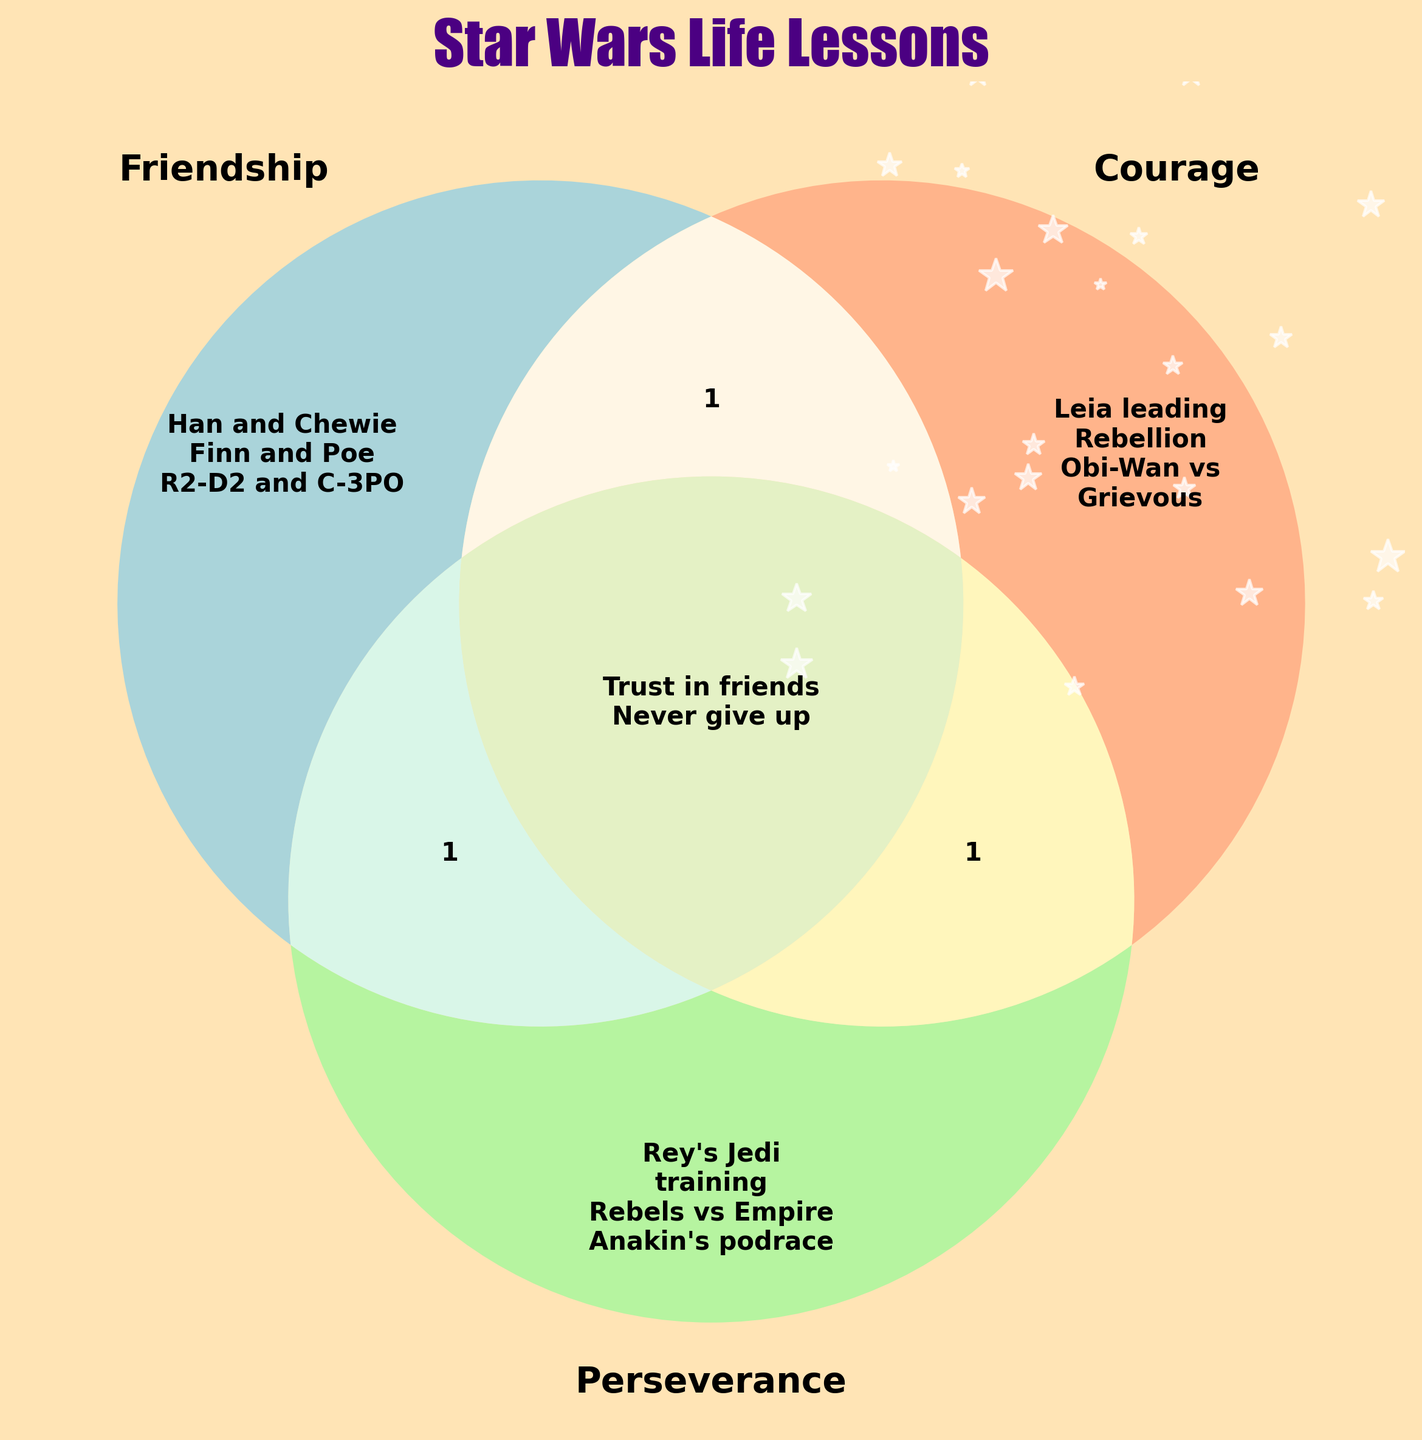What title is given to the figure? The title of the figure is displayed prominently above the Venn diagram in bold and large font, reading "Star Wars Life Lessons".
Answer: Star Wars Life Lessons What colors are used for each section of the Venn diagram? The Venn diagram uses three different colors: blue for Friendship, salmon for Courage, and light green for Perseverance.
Answer: Blue, Salmon, Light Green Which Star Wars lesson can be found in all three categories: Friendship, Courage, and Perseverance? In the middle section where all three circles overlap, the figure shows "Trust in friends" and "Never give up" indicating these lessons are shared by Friendship, Courage, and Perseverance.
Answer: Trust in friends, Never give up What Star Wars characters or themes represent the Friendship category alone? The section representing Friendship alone includes Han and Chewie, Finn and Poe, and R2-D2 and C-3PO.
Answer: Han and Chewie, Finn and Poe, R2-D2 and C-3PO Where is Leia leading the Rebellion placed in the diagram? Leia leading the Rebellion is placed in the section representing the Courage category alone, meaning it's a lesson solely of Courage.
Answer: Courage Which section includes concepts related to Perseverance alone? Perseverance alone includes Rey's Jedi training, Rebels vs Empire, and Anakin's podrace.
Answer: Rey's Jedi training, Rebels vs Empire, Anakin's podrace Are there any lessons that are not shared between any categories? If so, which ones? Each lesson is placed within a segment meaningfully; none are outside those defined segments. All lessons are shared within Friendship, Courage, or Perseverance, or combinations thereof.
Answer: No Which lesson is associated with both Friendship and Perseverance but not with Courage? In the overlapping area between Friendship and Perseverance but not Courage, the lesson shown is "Millennium Falcon crew".
Answer: Millennium Falcon crew What is the visual style of the labels within the Venn diagram? The labels within the Venn diagram are in bold font and vary slightly in size to fit nicely within the respective sections.
Answer: Bold font How many times do the lessons include something related to Jedi themes? In the sections, there are mentions of Jedi themes under Perseverance: Rey's Jedi training, Rebels vs Empire (involving Jedi), Anakin's podrace, and Jedi facing the dark side under Courage.
Answer: 4 